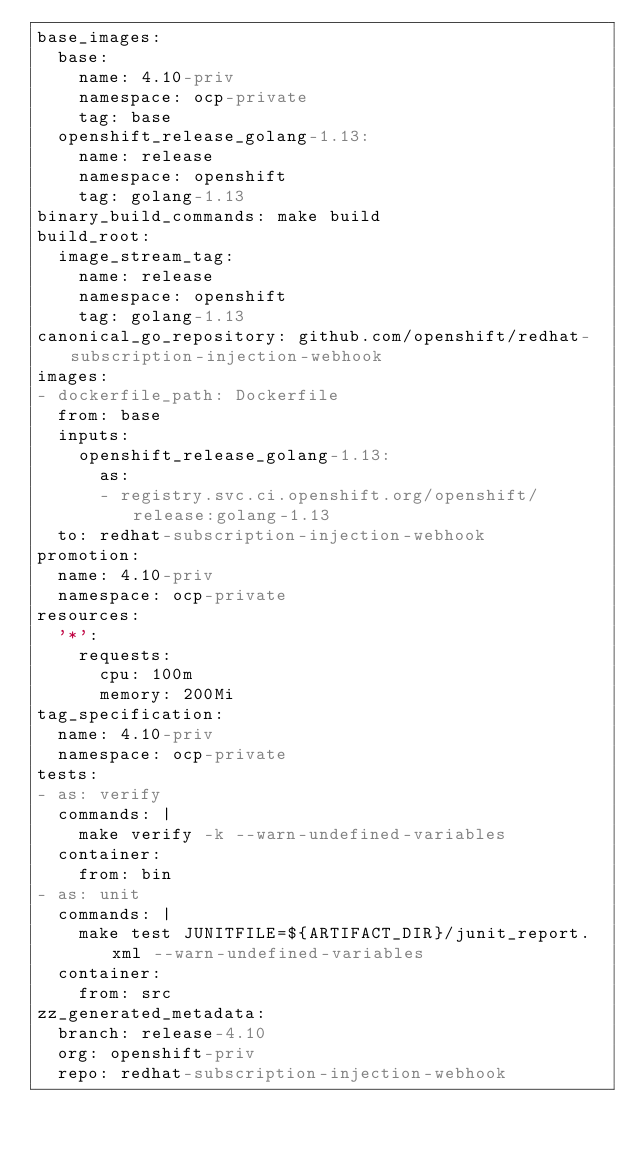Convert code to text. <code><loc_0><loc_0><loc_500><loc_500><_YAML_>base_images:
  base:
    name: 4.10-priv
    namespace: ocp-private
    tag: base
  openshift_release_golang-1.13:
    name: release
    namespace: openshift
    tag: golang-1.13
binary_build_commands: make build
build_root:
  image_stream_tag:
    name: release
    namespace: openshift
    tag: golang-1.13
canonical_go_repository: github.com/openshift/redhat-subscription-injection-webhook
images:
- dockerfile_path: Dockerfile
  from: base
  inputs:
    openshift_release_golang-1.13:
      as:
      - registry.svc.ci.openshift.org/openshift/release:golang-1.13
  to: redhat-subscription-injection-webhook
promotion:
  name: 4.10-priv
  namespace: ocp-private
resources:
  '*':
    requests:
      cpu: 100m
      memory: 200Mi
tag_specification:
  name: 4.10-priv
  namespace: ocp-private
tests:
- as: verify
  commands: |
    make verify -k --warn-undefined-variables
  container:
    from: bin
- as: unit
  commands: |
    make test JUNITFILE=${ARTIFACT_DIR}/junit_report.xml --warn-undefined-variables
  container:
    from: src
zz_generated_metadata:
  branch: release-4.10
  org: openshift-priv
  repo: redhat-subscription-injection-webhook
</code> 